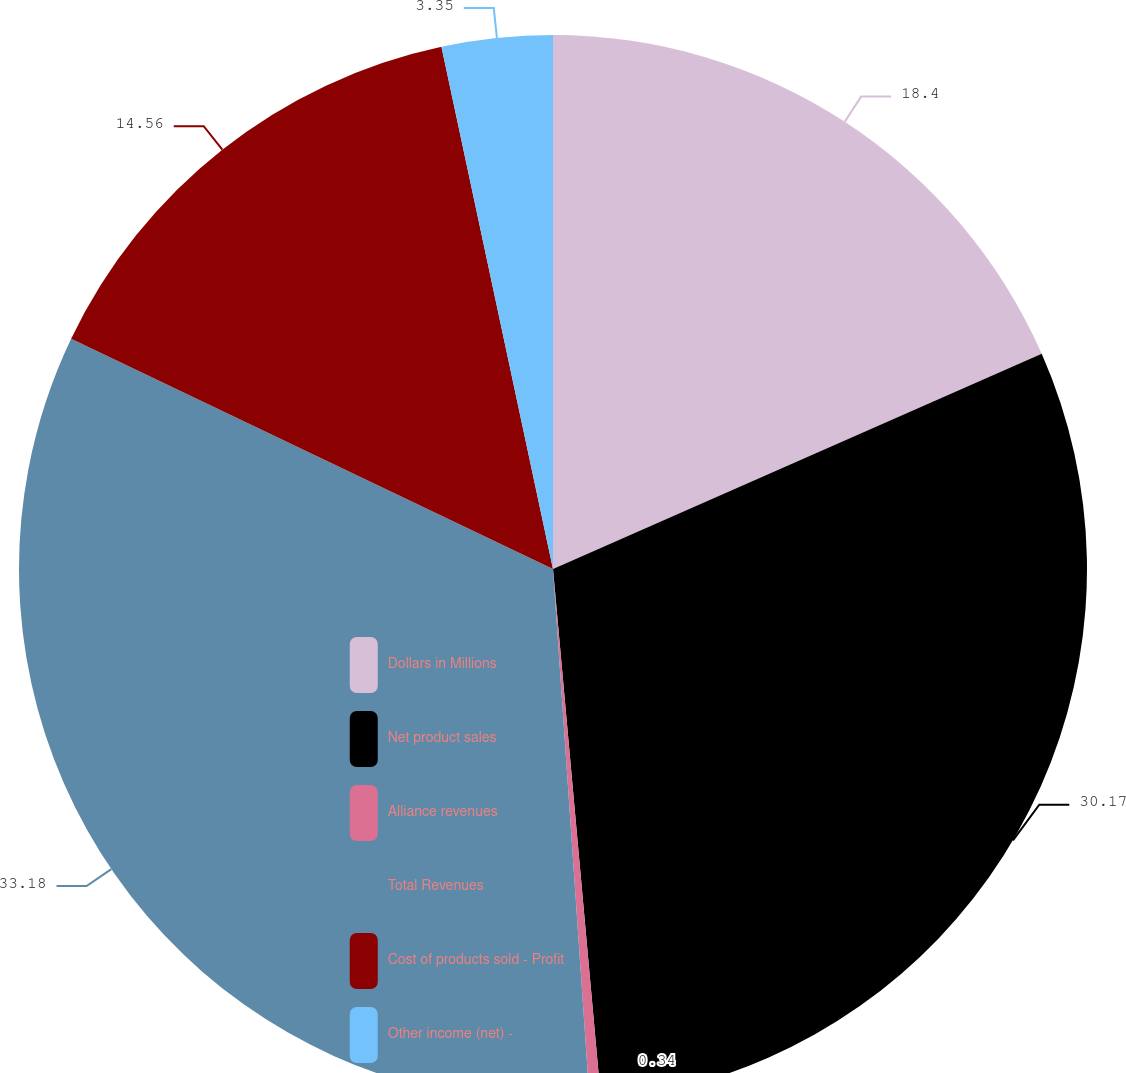<chart> <loc_0><loc_0><loc_500><loc_500><pie_chart><fcel>Dollars in Millions<fcel>Net product sales<fcel>Alliance revenues<fcel>Total Revenues<fcel>Cost of products sold - Profit<fcel>Other income (net) -<nl><fcel>18.4%<fcel>30.17%<fcel>0.34%<fcel>33.19%<fcel>14.56%<fcel>3.35%<nl></chart> 